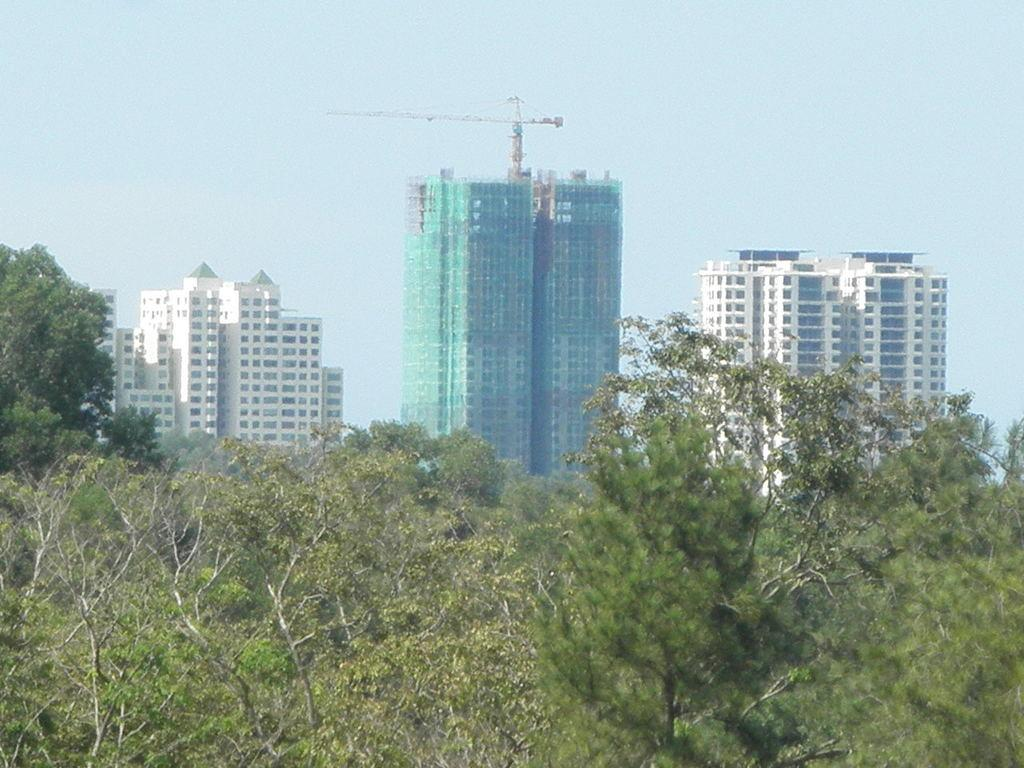What type of structures can be seen in the image? There are buildings in the image. What other natural elements are present in the image? There are trees in the image. How would you describe the weather based on the sky in the image? The sky is cloudy in the image. How many holes can be seen in the buildings in the image? There are no holes mentioned or visible in the buildings in the image. What invention is being used by the trees in the image? There is no invention associated with the trees in the image. 